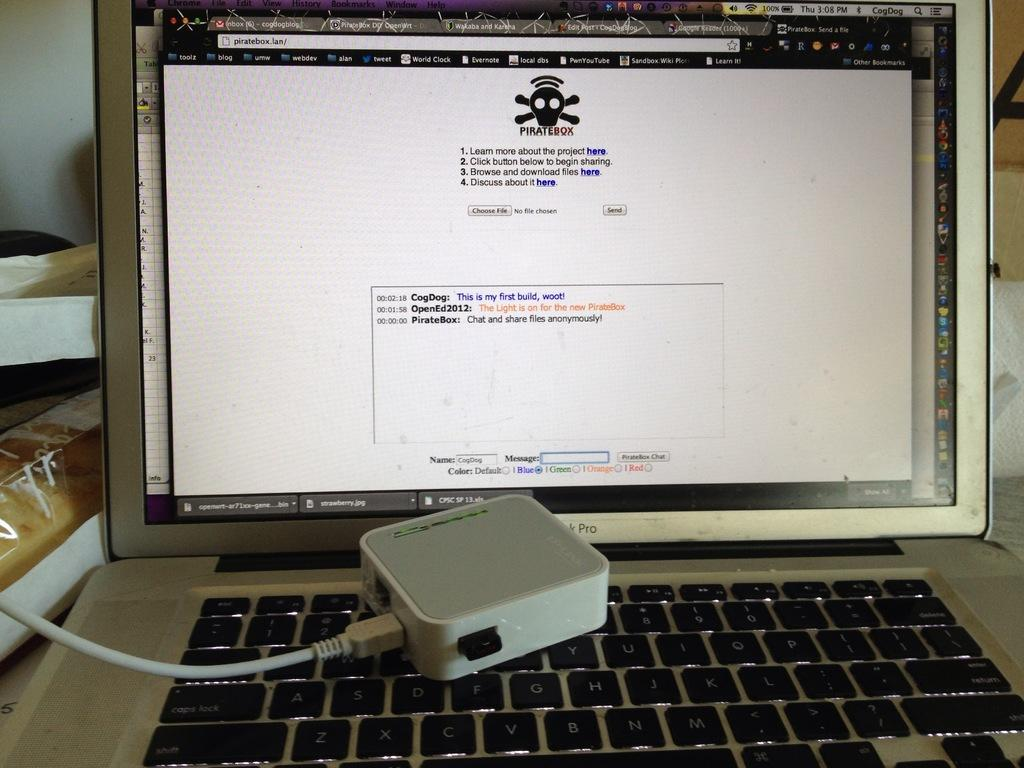<image>
Provide a brief description of the given image. A MacBook Pro laptop open to the website piratebox.lan 